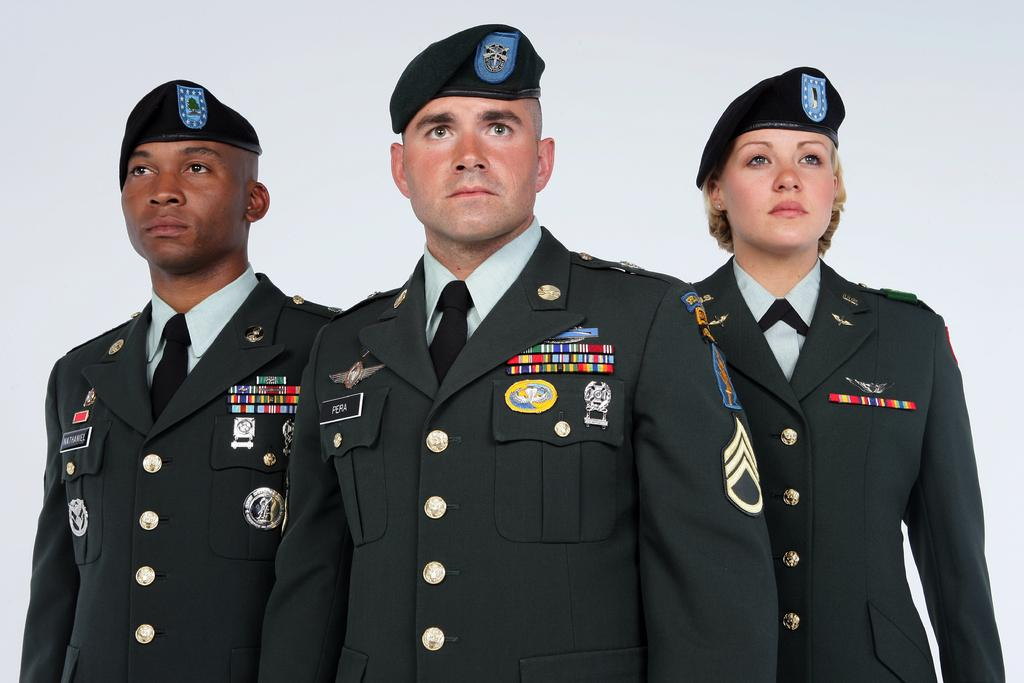How many people are in the image? There are persons in the image, but the exact number is not specified. What are the persons wearing? The persons are wearing clothes and caps. Where is the bucket located in the image? There is no bucket present in the image. What type of love is being expressed by the persons in the image? The image does not depict any expressions of love, as it only shows persons wearing clothes and caps. 